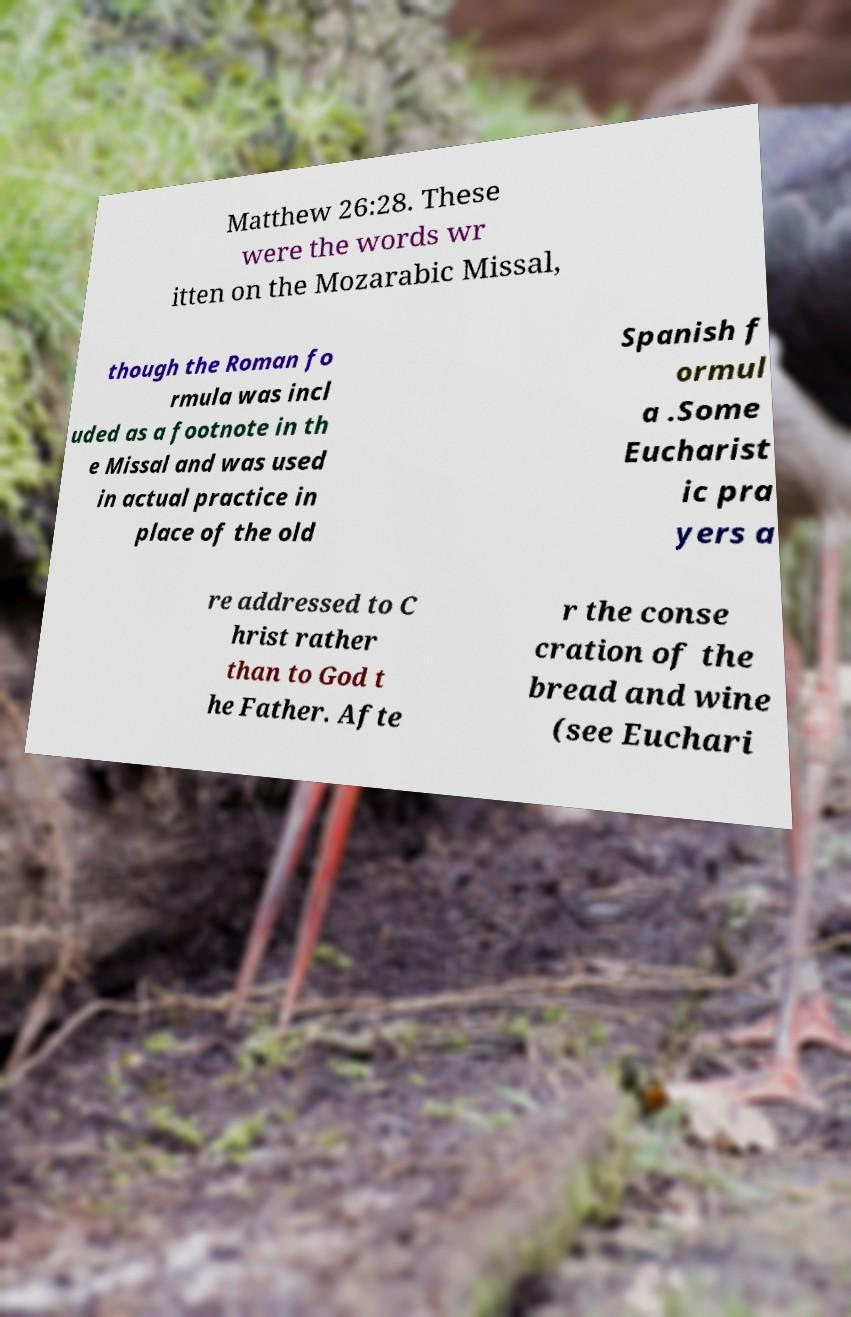Could you assist in decoding the text presented in this image and type it out clearly? Matthew 26:28. These were the words wr itten on the Mozarabic Missal, though the Roman fo rmula was incl uded as a footnote in th e Missal and was used in actual practice in place of the old Spanish f ormul a .Some Eucharist ic pra yers a re addressed to C hrist rather than to God t he Father. Afte r the conse cration of the bread and wine (see Euchari 